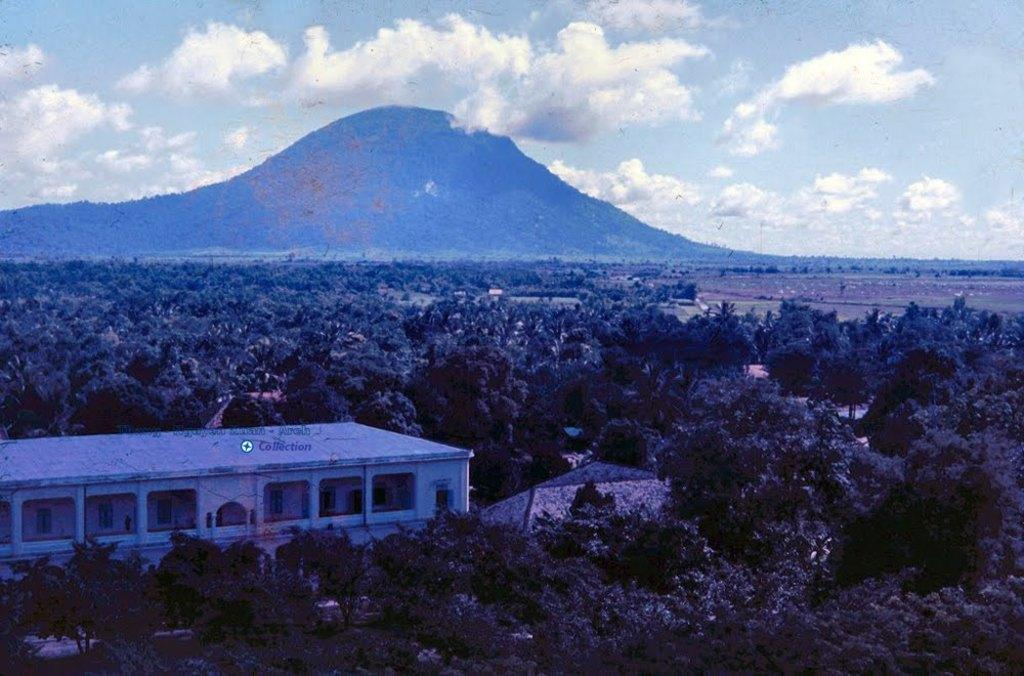What type of natural elements can be seen in the image? There are trees in the image. What type of man-made structures are present in the image? There are buildings in the image. What can be seen in the background of the image? The ground, a mountain, and the sky are visible in the background of the image. What type of tomatoes can be heard in the image? There are no tomatoes present in the image, and therefore no sounds can be heard from them. Is the minister visible in the image? There is no mention of a minister in the provided facts, so it cannot be determined if one is present in the image. 